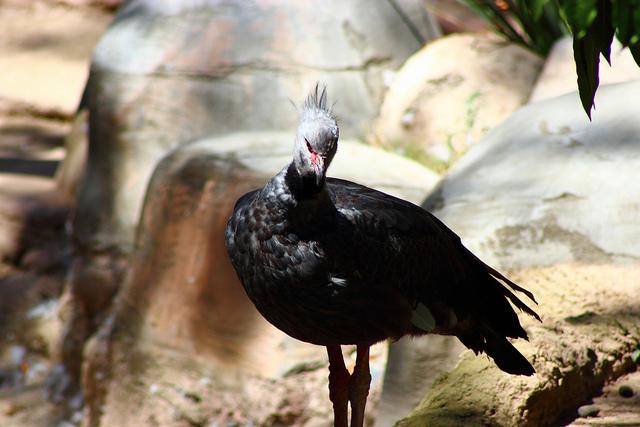What color is it's feathers?
Keep it brief. Black. What kind of bird is pictured?
Keep it brief. Vulture. Is this bird in a rocky area?
Be succinct. Yes. 